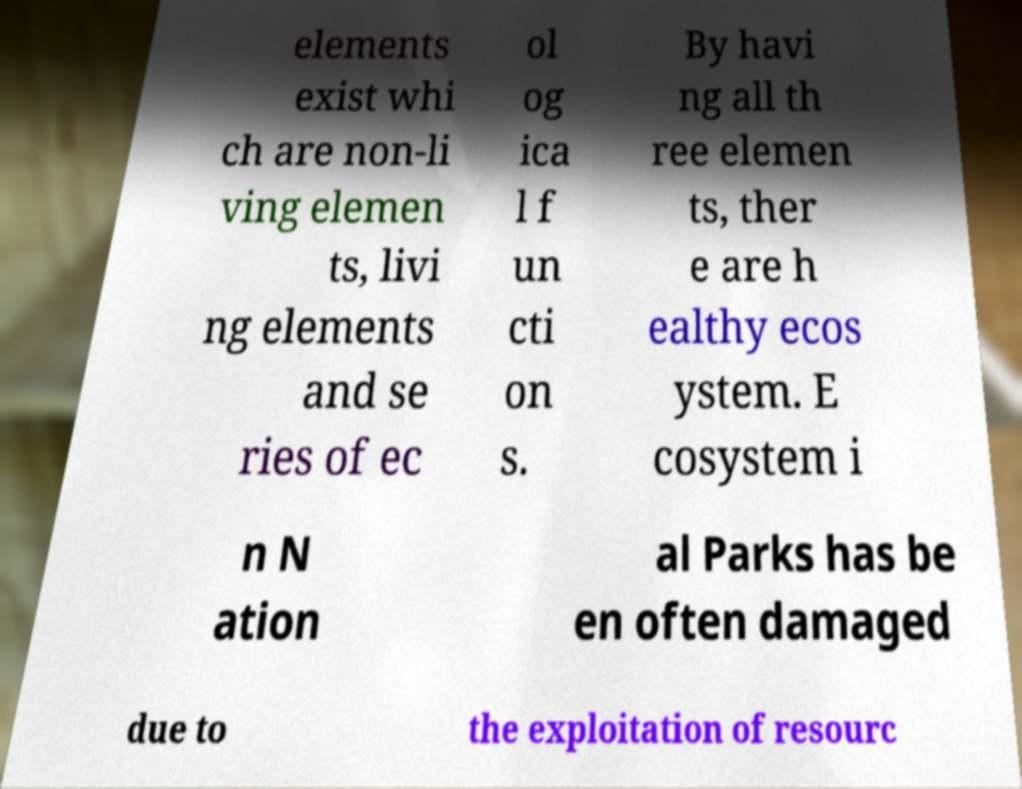For documentation purposes, I need the text within this image transcribed. Could you provide that? elements exist whi ch are non-li ving elemen ts, livi ng elements and se ries of ec ol og ica l f un cti on s. By havi ng all th ree elemen ts, ther e are h ealthy ecos ystem. E cosystem i n N ation al Parks has be en often damaged due to the exploitation of resourc 